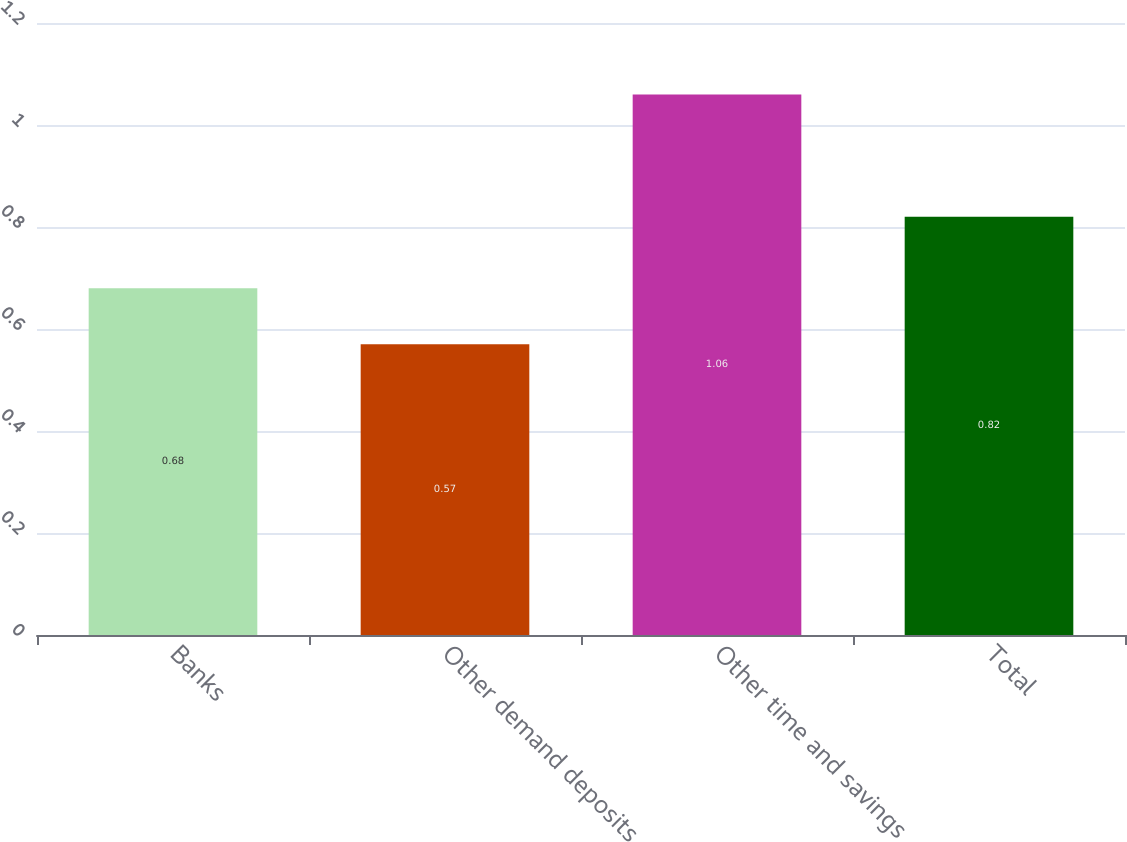<chart> <loc_0><loc_0><loc_500><loc_500><bar_chart><fcel>Banks<fcel>Other demand deposits<fcel>Other time and savings<fcel>Total<nl><fcel>0.68<fcel>0.57<fcel>1.06<fcel>0.82<nl></chart> 